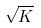Convert formula to latex. <formula><loc_0><loc_0><loc_500><loc_500>\sqrt { K }</formula> 